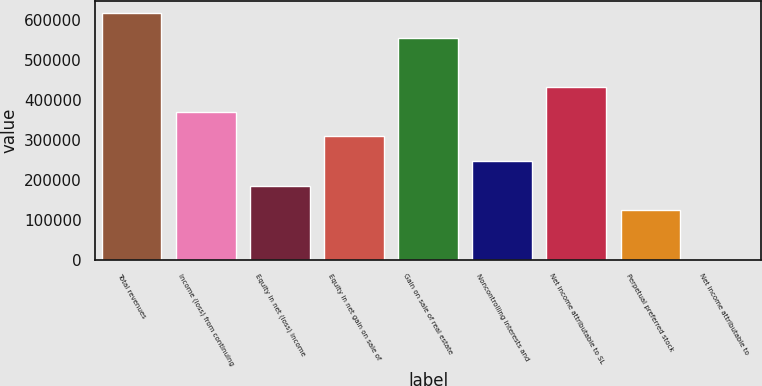Convert chart. <chart><loc_0><loc_0><loc_500><loc_500><bar_chart><fcel>Total revenues<fcel>Income (loss) from continuing<fcel>Equity in net (loss) income<fcel>Equity in net gain on sale of<fcel>Gain on sale of real estate<fcel>Noncontrolling interests and<fcel>Net income attributable to SL<fcel>Perpetual preferred stock<fcel>Net income attributable to<nl><fcel>617614<fcel>370569<fcel>185285<fcel>308808<fcel>555853<fcel>247046<fcel>432330<fcel>123524<fcel>1.33<nl></chart> 